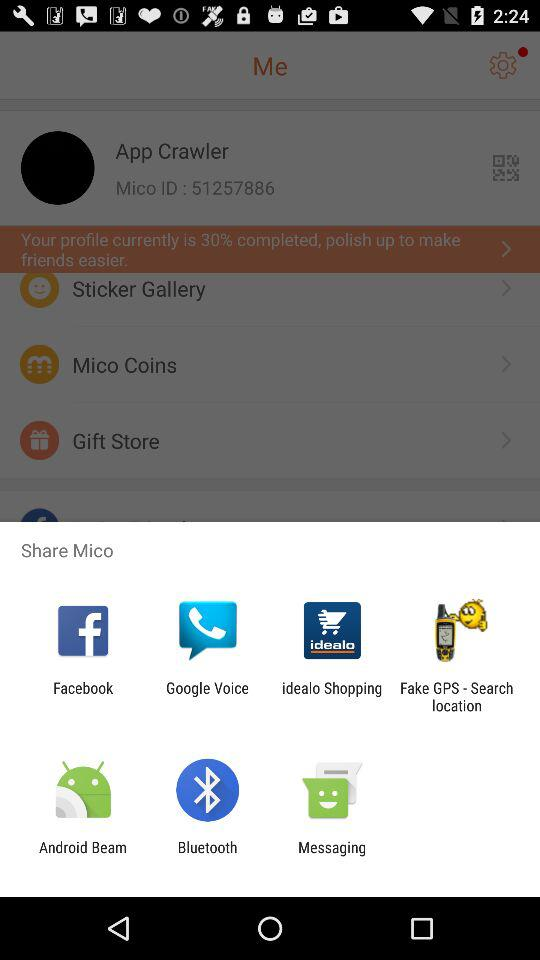With what apps can we share it? The apps are "Facebook", " Google Voice", "idealo Shopping", "Fake GPS - Search location", "Android Beam", "Bluetooth" and "Messaging". 